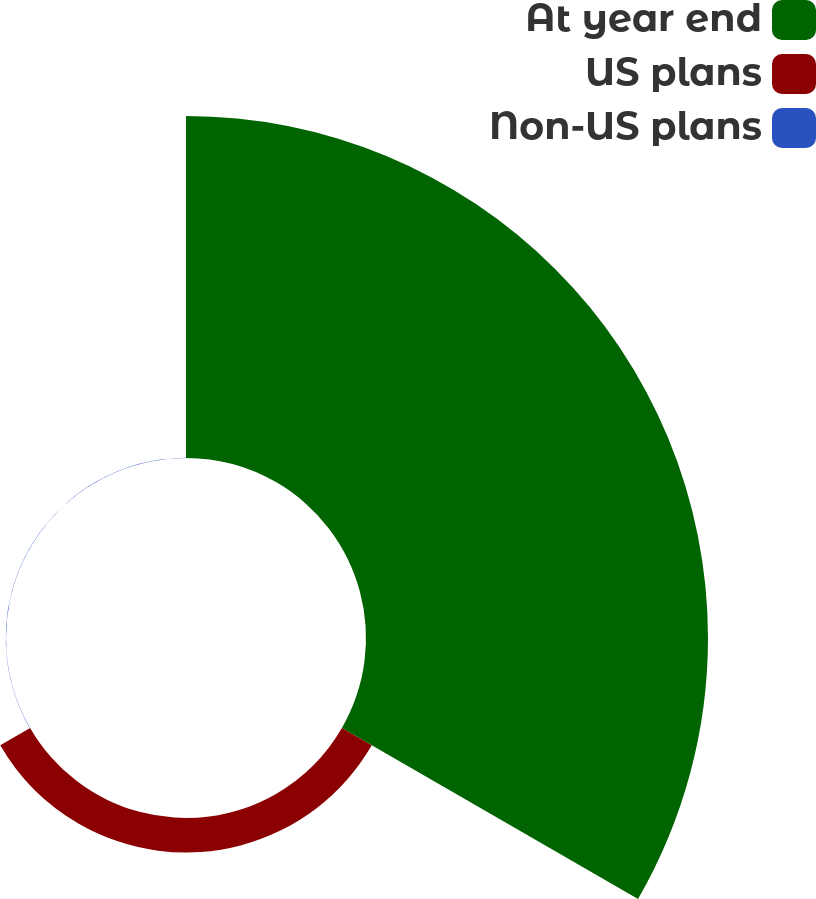Convert chart to OTSL. <chart><loc_0><loc_0><loc_500><loc_500><pie_chart><fcel>At year end<fcel>US plans<fcel>Non-US plans<nl><fcel>90.77%<fcel>9.15%<fcel>0.08%<nl></chart> 